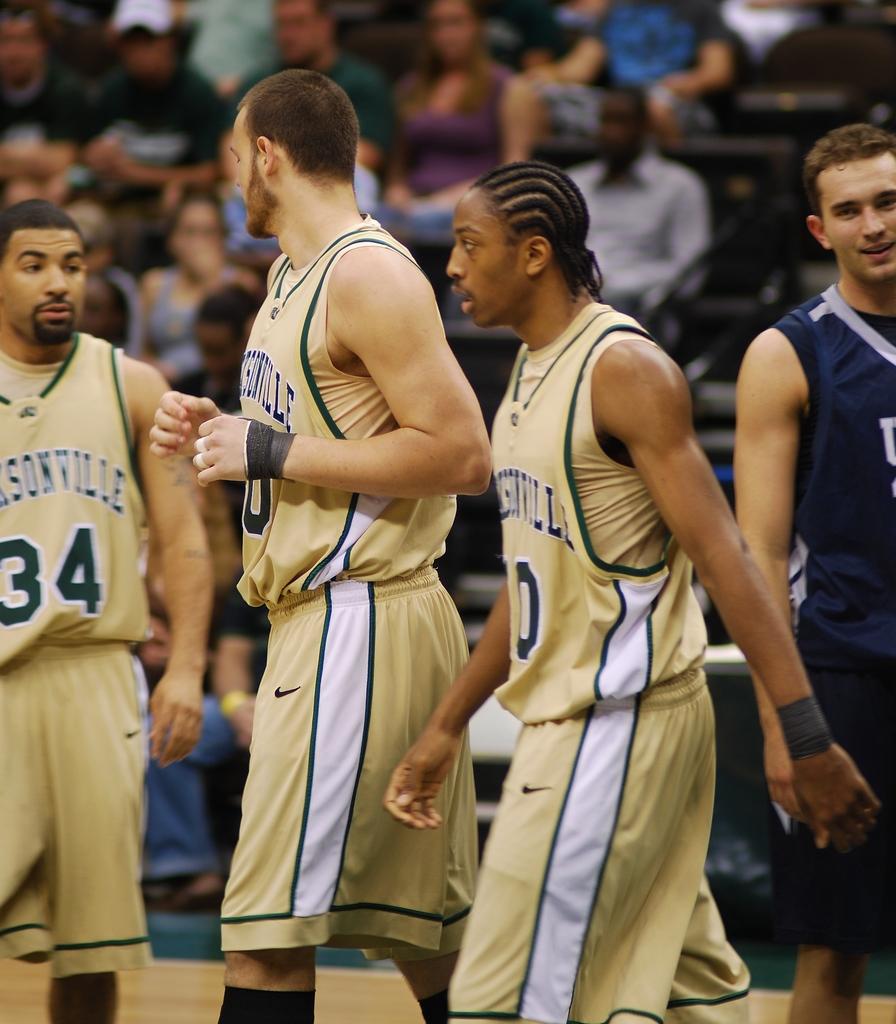What number does the player on the far left have on?
Ensure brevity in your answer.  34. 